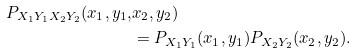<formula> <loc_0><loc_0><loc_500><loc_500>P _ { X _ { 1 } Y _ { 1 } X _ { 2 } Y _ { 2 } } ( x _ { 1 } , y _ { 1 } , & x _ { 2 } , y _ { 2 } ) \\ & = P _ { X _ { 1 } Y _ { 1 } } ( x _ { 1 } , y _ { 1 } ) P _ { X _ { 2 } Y _ { 2 } } ( x _ { 2 } , y _ { 2 } ) .</formula> 